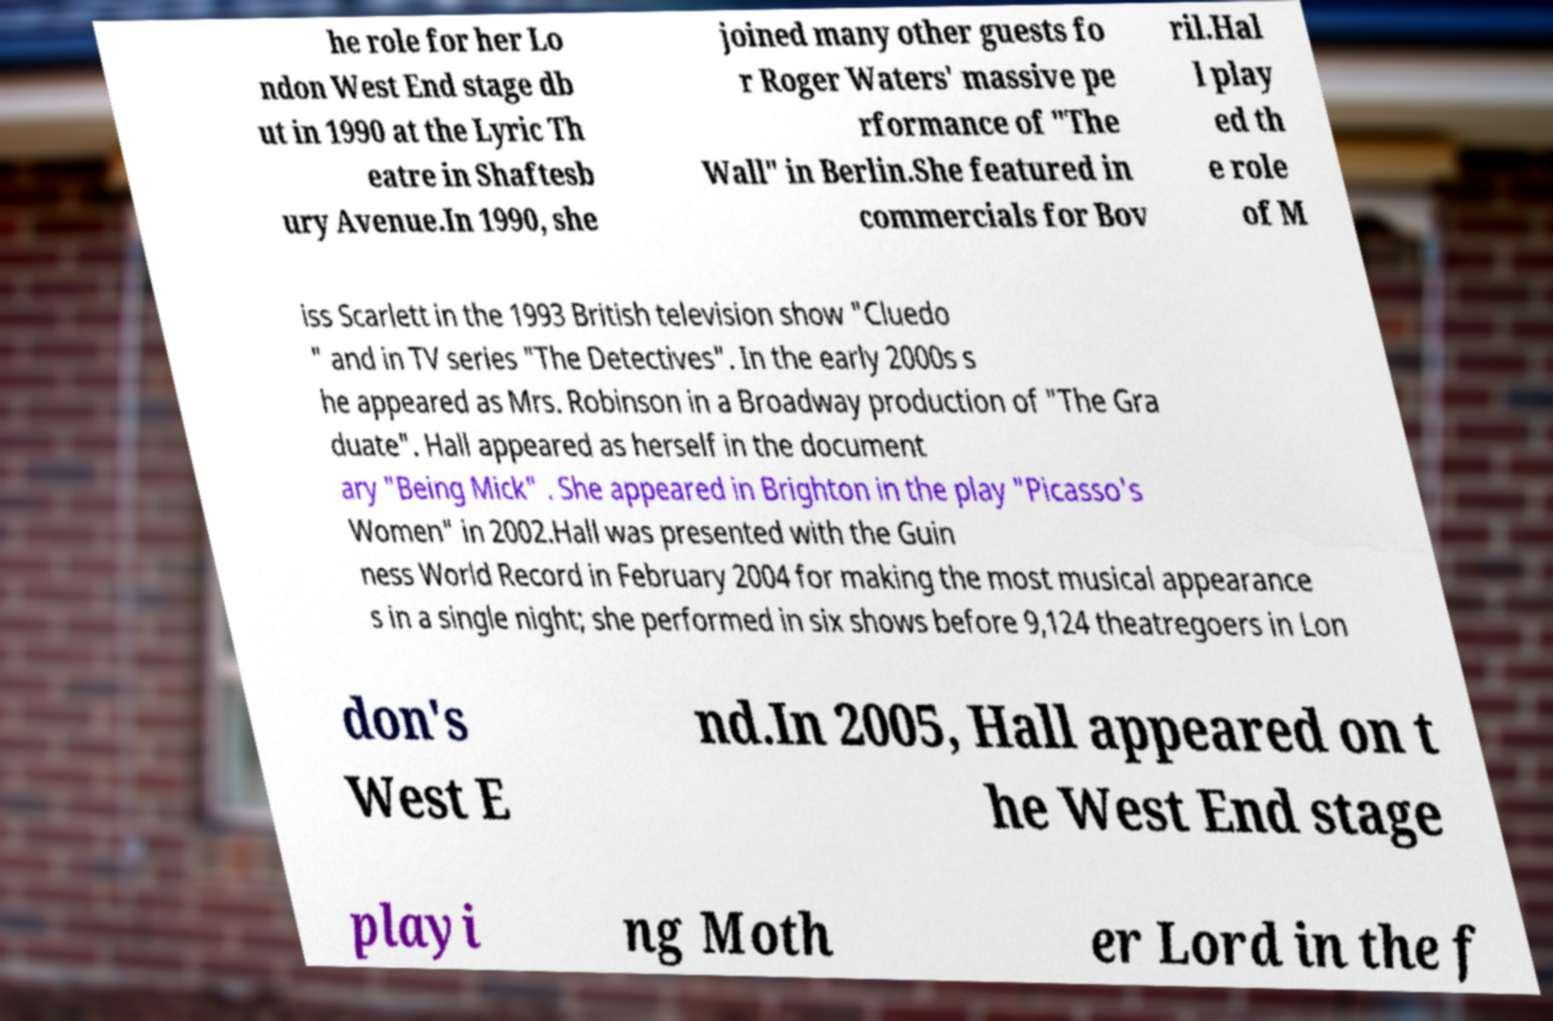Please read and relay the text visible in this image. What does it say? he role for her Lo ndon West End stage db ut in 1990 at the Lyric Th eatre in Shaftesb ury Avenue.In 1990, she joined many other guests fo r Roger Waters' massive pe rformance of "The Wall" in Berlin.She featured in commercials for Bov ril.Hal l play ed th e role of M iss Scarlett in the 1993 British television show "Cluedo " and in TV series "The Detectives". In the early 2000s s he appeared as Mrs. Robinson in a Broadway production of "The Gra duate". Hall appeared as herself in the document ary "Being Mick" . She appeared in Brighton in the play "Picasso's Women" in 2002.Hall was presented with the Guin ness World Record in February 2004 for making the most musical appearance s in a single night; she performed in six shows before 9,124 theatregoers in Lon don's West E nd.In 2005, Hall appeared on t he West End stage playi ng Moth er Lord in the f 